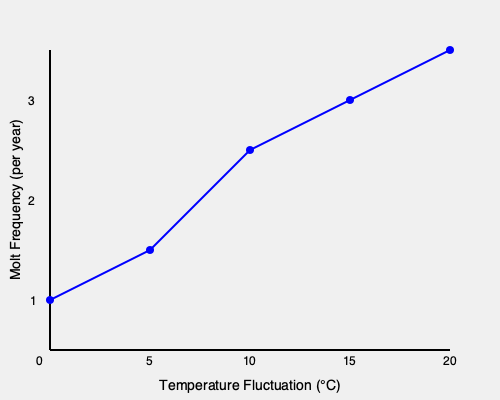Based on the graph, what is the approximate rate of increase in molt frequency per 5°C increase in temperature fluctuation? To determine the rate of increase in molt frequency per 5°C increase in temperature fluctuation, we need to follow these steps:

1. Identify two points on the graph that are 5°C apart on the x-axis.
2. Calculate the difference in molt frequency between these two points.
3. Repeat this process for multiple pairs of points to ensure consistency.

Let's analyze the graph:

a) From 0°C to 5°C:
   At 0°C: Molt frequency ≈ 1.0 per year
   At 5°C: Molt frequency ≈ 1.5 per year
   Increase: 1.5 - 1.0 = 0.5 per year

b) From 5°C to 10°C:
   At 5°C: Molt frequency ≈ 1.5 per year
   At 10°C: Molt frequency ≈ 2.25 per year
   Increase: 2.25 - 1.5 = 0.75 per year

c) From 10°C to 15°C:
   At 10°C: Molt frequency ≈ 2.25 per year
   At 15°C: Molt frequency ≈ 2.75 per year
   Increase: 2.75 - 2.25 = 0.5 per year

We can see that the rate of increase is not perfectly consistent, but it averages around 0.5 to 0.75 molts per year for each 5°C increase in temperature fluctuation.

Taking the average of these values: $(0.5 + 0.75 + 0.5) / 3 = 0.58$

Therefore, the approximate rate of increase in molt frequency is 0.58 molts per year for every 5°C increase in temperature fluctuation.
Answer: 0.58 molts per year 